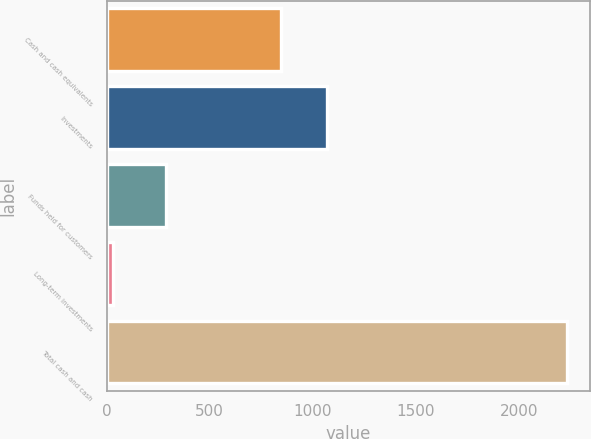Convert chart. <chart><loc_0><loc_0><loc_500><loc_500><bar_chart><fcel>Cash and cash equivalents<fcel>Investments<fcel>Funds held for customers<fcel>Long-term investments<fcel>Total cash and cash<nl><fcel>849<fcel>1069.2<fcel>289<fcel>31<fcel>2233<nl></chart> 